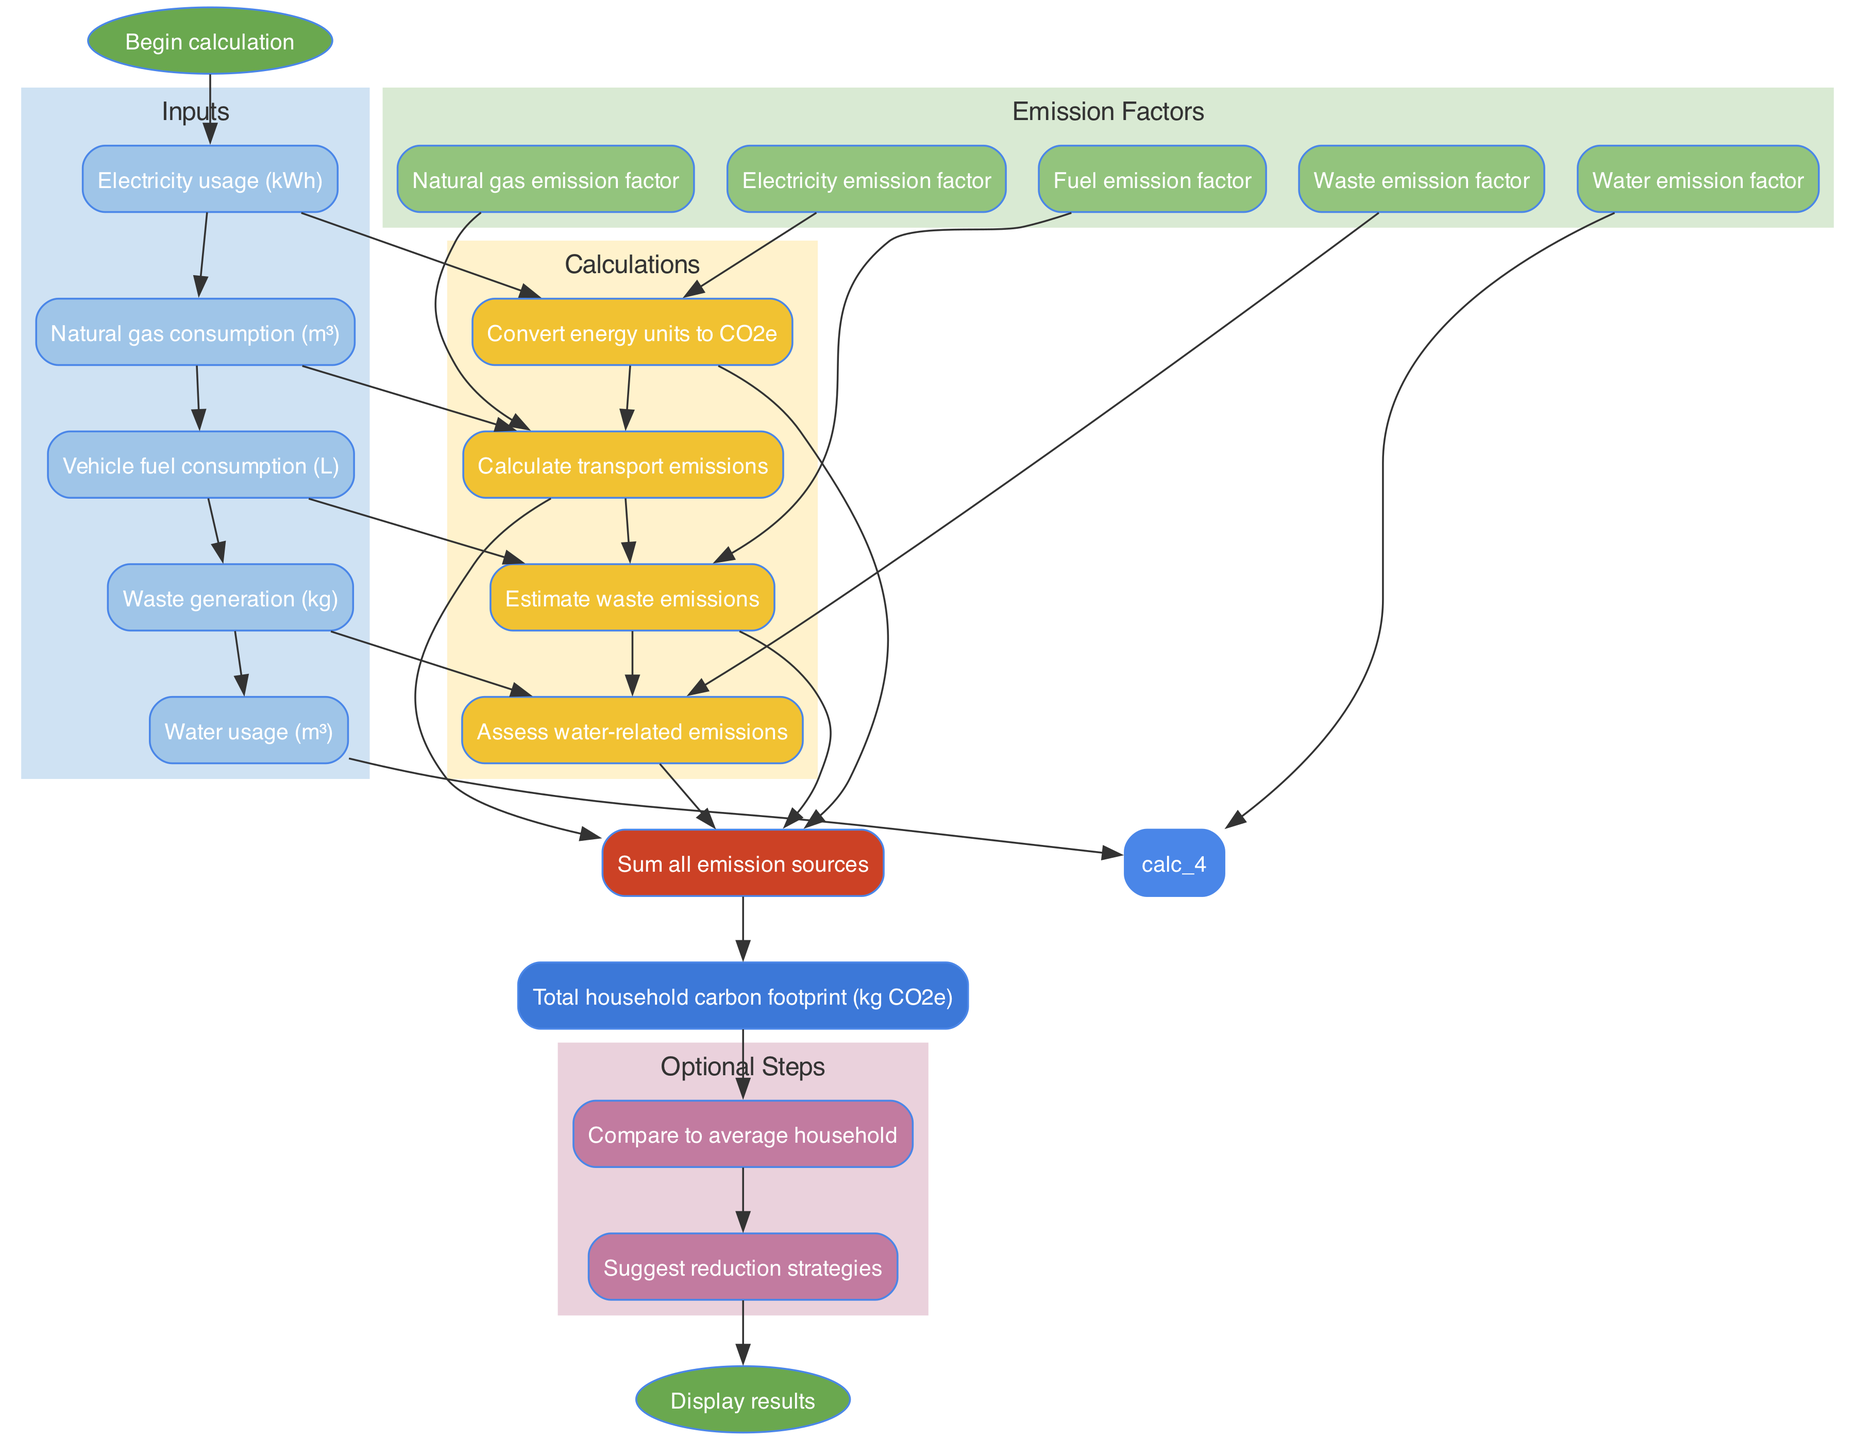What is the first step in the carbon footprint calculation? The diagram indicates that the first step is the "Begin calculation" node, which initiates the entire flow process.
Answer: Begin calculation How many inputs are required for the calculation? The diagram shows five distinct input nodes, representing different consumption metrics needed to compute the carbon footprint.
Answer: Five What is the output of the calculation? The diagram specifies that the final output provided at the end of the flow is the "Total household carbon footprint (kg CO2e)", summarizing the emissions calculated from the inputs and factors.
Answer: Total household carbon footprint (kg CO2e) What do the calculation nodes lead to? Each calculation node leads directly to the aggregation node, indicating that results from multiple calculations are combined into a single result.
Answer: Aggregation Do input factors directly connect to the aggregation node? No, the input factors connect to their respective calculation nodes, which then lead to the aggregation node. Therefore, they do not connect directly to the aggregation node.
Answer: No What is the purpose of the optional steps after the output? The optional steps allow for further actions, specifically to "Compare to average household" and "Suggest reduction strategies," providing additional context and options for the user.
Answer: Compare to average household and Suggest reduction strategies How many types of calculations are there? The diagram illustrates four different calculation nodes in the process, each corresponding to a specific aspect of carbon emissions from various household activities.
Answer: Four Which color represents the emissions factors in the diagram? The emission factors are shown in a light green color, identified by the node fill color in the diagram structure.
Answer: Light green What connects the aggregation to the output? The diagram features a direct edge connecting the "aggregation" node to the "output", indicating that all calculated emissions are summed before producing the final result.
Answer: Direct edge 